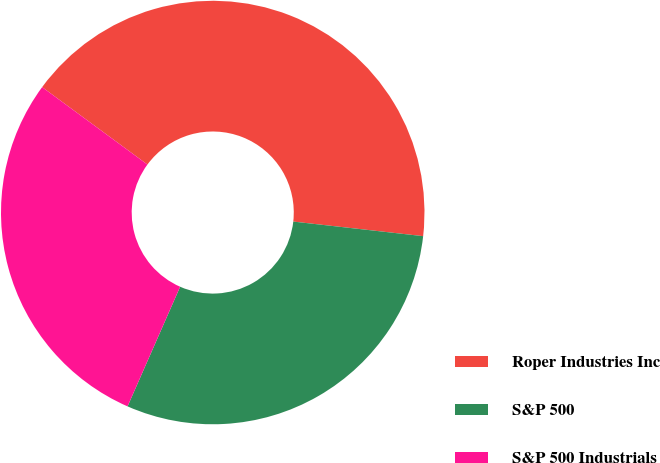Convert chart. <chart><loc_0><loc_0><loc_500><loc_500><pie_chart><fcel>Roper Industries Inc<fcel>S&P 500<fcel>S&P 500 Industrials<nl><fcel>41.69%<fcel>29.81%<fcel>28.5%<nl></chart> 